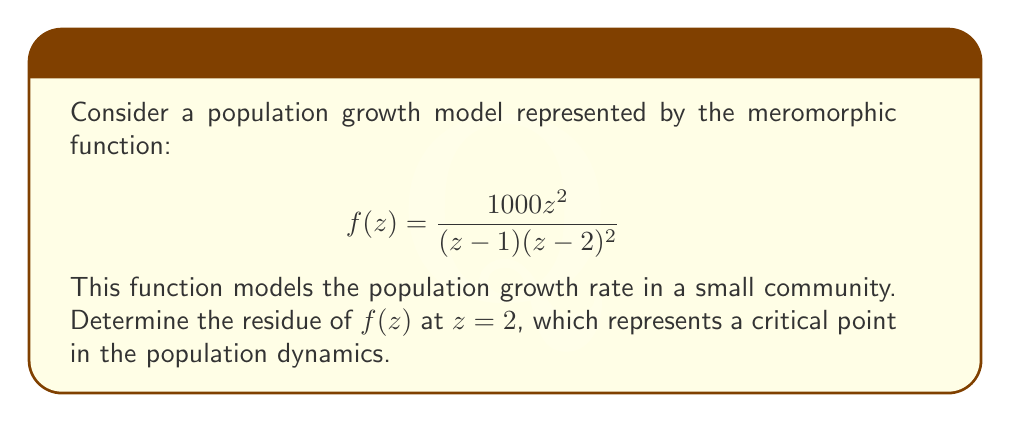Can you solve this math problem? To find the residue of $f(z)$ at $z=2$, we need to follow these steps:

1) First, we identify that $z=2$ is a pole of order 2 for $f(z)$.

2) For a pole of order 2, we use the formula:

   $$\text{Res}(f,2) = \lim_{z \to 2} \frac{d}{dz}\left[(z-2)^2f(z)\right]$$

3) Let's simplify $(z-2)^2f(z)$:

   $$(z-2)^2f(z) = (z-2)^2 \cdot \frac{1000z^2}{(z-1)(z-2)^2} = \frac{1000z^2}{z-1}$$

4) Now we differentiate this with respect to $z$:

   $$\frac{d}{dz}\left[\frac{1000z^2}{z-1}\right] = 1000 \cdot \frac{2z(z-1) - z^2}{(z-1)^2} = 1000 \cdot \frac{z^2-2z}{(z-1)^2}$$

5) Finally, we take the limit as $z$ approaches 2:

   $$\lim_{z \to 2} 1000 \cdot \frac{z^2-2z}{(z-1)^2} = 1000 \cdot \frac{4-4}{(2-1)^2} = 1000 \cdot \frac{0}{1} = 0$$

Therefore, the residue of $f(z)$ at $z=2$ is 0.

This result suggests that at this critical point in the population dynamics, the net contribution to the overall growth is neutral, which could indicate a temporary equilibrium or turning point in the population trend.
Answer: The residue of $f(z)$ at $z=2$ is 0. 